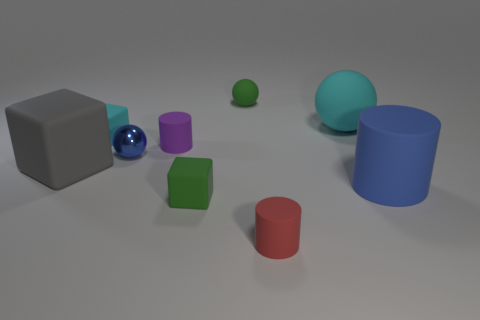Does the metallic sphere have the same size as the blue rubber cylinder?
Provide a succinct answer. No. Does the small purple thing have the same shape as the tiny cyan object?
Make the answer very short. No. What number of other objects are the same size as the red cylinder?
Offer a terse response. 5. What is the color of the large sphere?
Your answer should be very brief. Cyan. What number of big objects are purple rubber blocks or cyan things?
Your answer should be compact. 1. Does the cyan object that is on the right side of the tiny blue metallic sphere have the same size as the gray matte cube behind the tiny red rubber thing?
Your response must be concise. Yes. There is a green object that is the same shape as the tiny cyan object; what is its size?
Keep it short and to the point. Small. Is the number of cyan things on the left side of the tiny purple matte thing greater than the number of tiny red cylinders that are on the left side of the big block?
Provide a short and direct response. Yes. What is the object that is in front of the metallic object and on the right side of the red cylinder made of?
Make the answer very short. Rubber. The tiny metal thing that is the same shape as the big cyan object is what color?
Keep it short and to the point. Blue. 